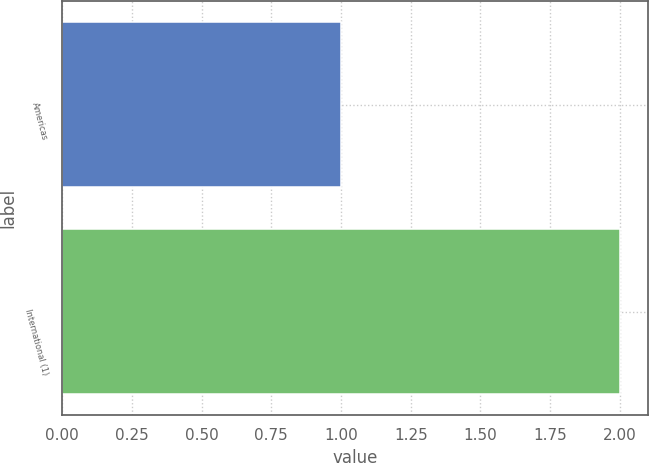Convert chart to OTSL. <chart><loc_0><loc_0><loc_500><loc_500><bar_chart><fcel>Americas<fcel>International (1)<nl><fcel>1<fcel>2<nl></chart> 